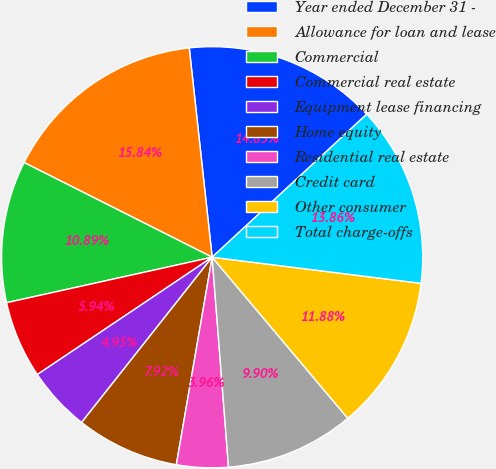Convert chart to OTSL. <chart><loc_0><loc_0><loc_500><loc_500><pie_chart><fcel>Year ended December 31 -<fcel>Allowance for loan and lease<fcel>Commercial<fcel>Commercial real estate<fcel>Equipment lease financing<fcel>Home equity<fcel>Residential real estate<fcel>Credit card<fcel>Other consumer<fcel>Total charge-offs<nl><fcel>14.85%<fcel>15.84%<fcel>10.89%<fcel>5.94%<fcel>4.95%<fcel>7.92%<fcel>3.96%<fcel>9.9%<fcel>11.88%<fcel>13.86%<nl></chart> 